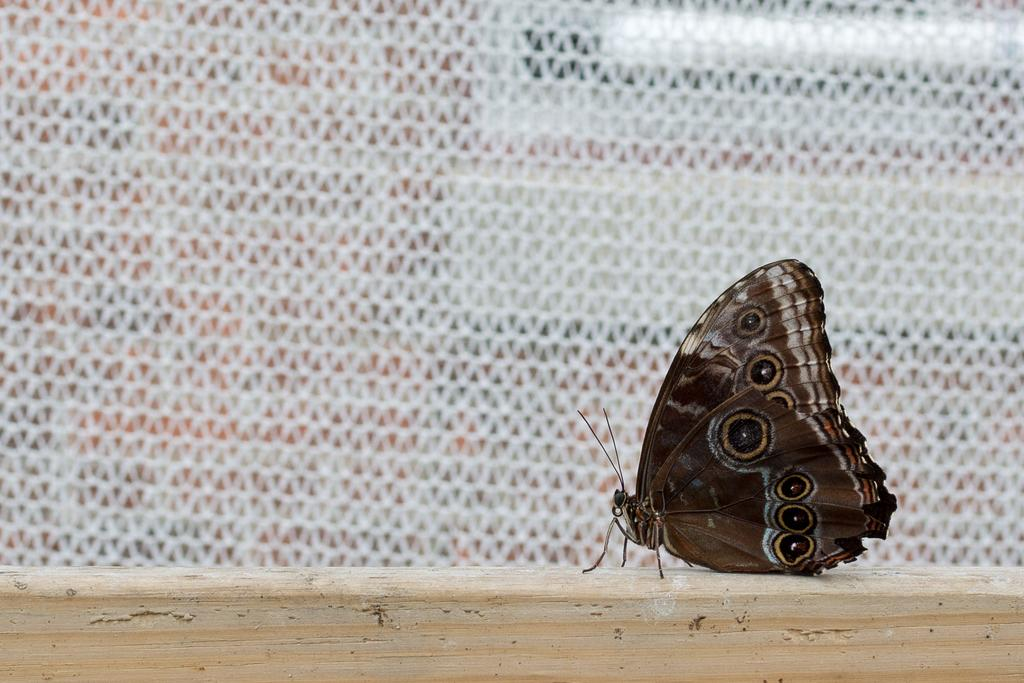What is the main subject of the image? There is a butterfly on a wooden surface in the image. Can you describe the surface where the butterfly is resting? The butterfly is resting on a wooden surface. What else can be seen in the background of the image? There is a net visible in the background of the image. How many cars are parked under the icicle in the image? There are no cars or icicles present in the image; it features a butterfly on a wooden surface with a net visible in the background. 